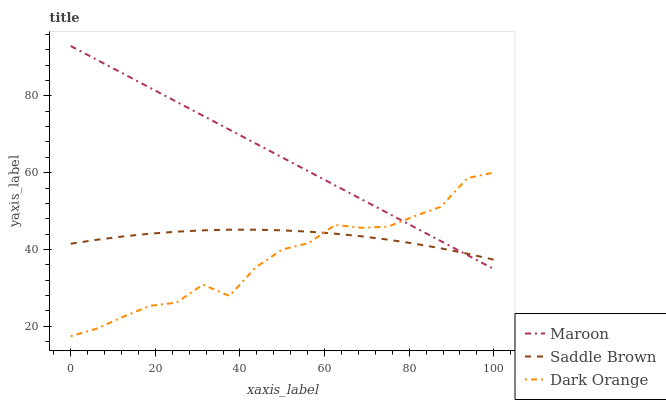Does Dark Orange have the minimum area under the curve?
Answer yes or no. Yes. Does Maroon have the maximum area under the curve?
Answer yes or no. Yes. Does Saddle Brown have the minimum area under the curve?
Answer yes or no. No. Does Saddle Brown have the maximum area under the curve?
Answer yes or no. No. Is Maroon the smoothest?
Answer yes or no. Yes. Is Dark Orange the roughest?
Answer yes or no. Yes. Is Saddle Brown the smoothest?
Answer yes or no. No. Is Saddle Brown the roughest?
Answer yes or no. No. Does Maroon have the lowest value?
Answer yes or no. No. Does Maroon have the highest value?
Answer yes or no. Yes. Does Saddle Brown have the highest value?
Answer yes or no. No. Does Maroon intersect Saddle Brown?
Answer yes or no. Yes. Is Maroon less than Saddle Brown?
Answer yes or no. No. Is Maroon greater than Saddle Brown?
Answer yes or no. No. 